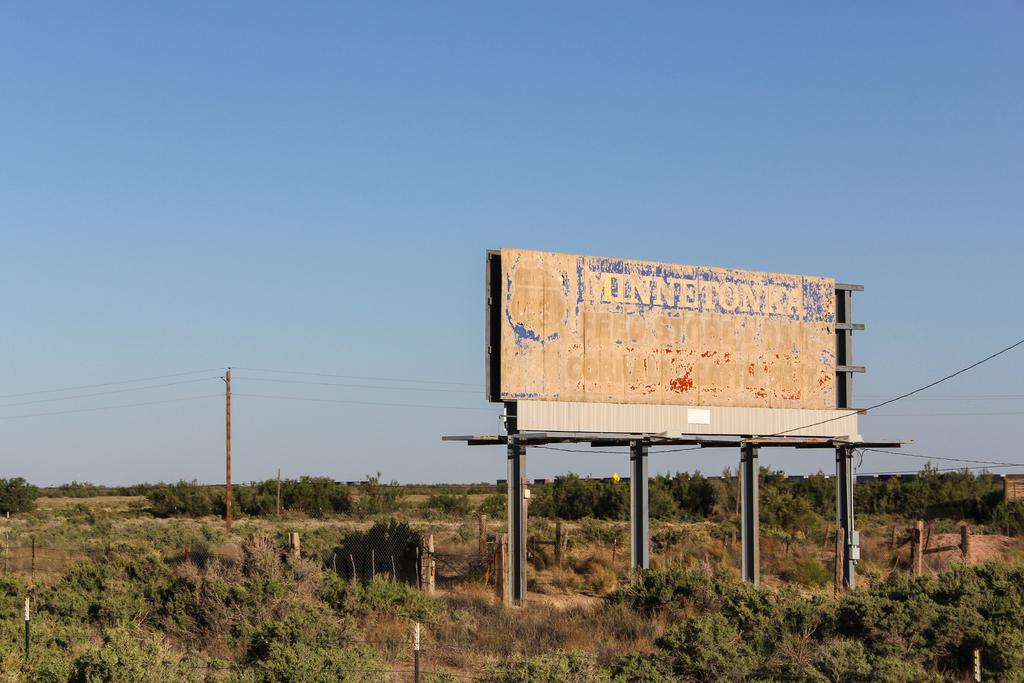What is the main structure visible in the image? There is a hoarding in the image. What other objects can be seen in the image? There are poles, wires, a fence, and trees visible in the image. What is the background of the image? The sky is visible in the background of the image. Can you tell me how many sticks the porter is carrying in the image? There is no porter or stick present in the image. What type of crook is shown leaning against the fence in the image? There is no crook or fence present in the image; it only features a hoarding, poles, wires, and trees. 